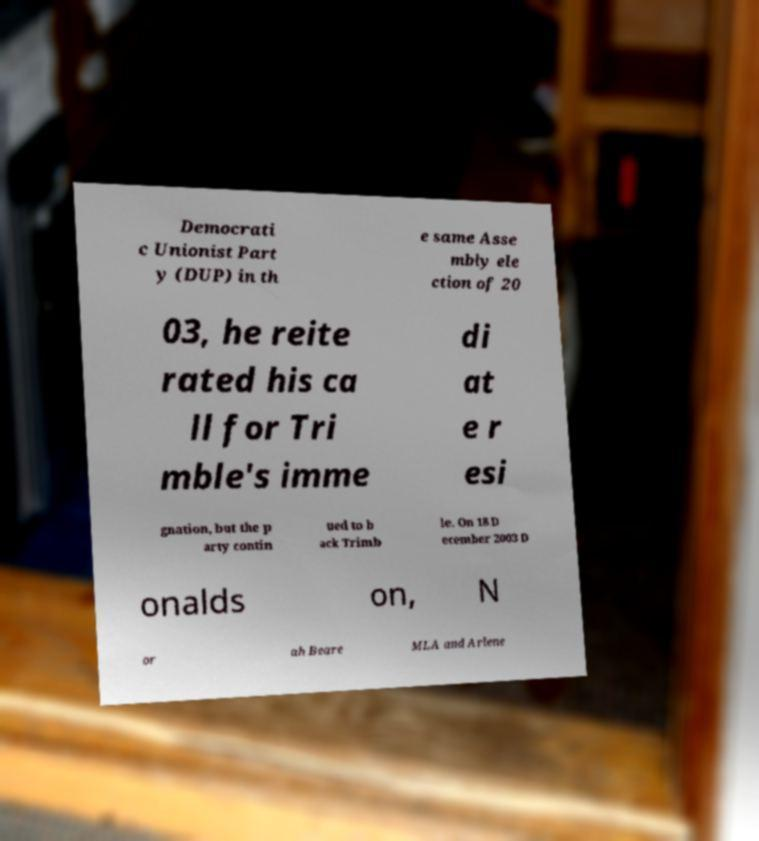There's text embedded in this image that I need extracted. Can you transcribe it verbatim? Democrati c Unionist Part y (DUP) in th e same Asse mbly ele ction of 20 03, he reite rated his ca ll for Tri mble's imme di at e r esi gnation, but the p arty contin ued to b ack Trimb le. On 18 D ecember 2003 D onalds on, N or ah Beare MLA and Arlene 